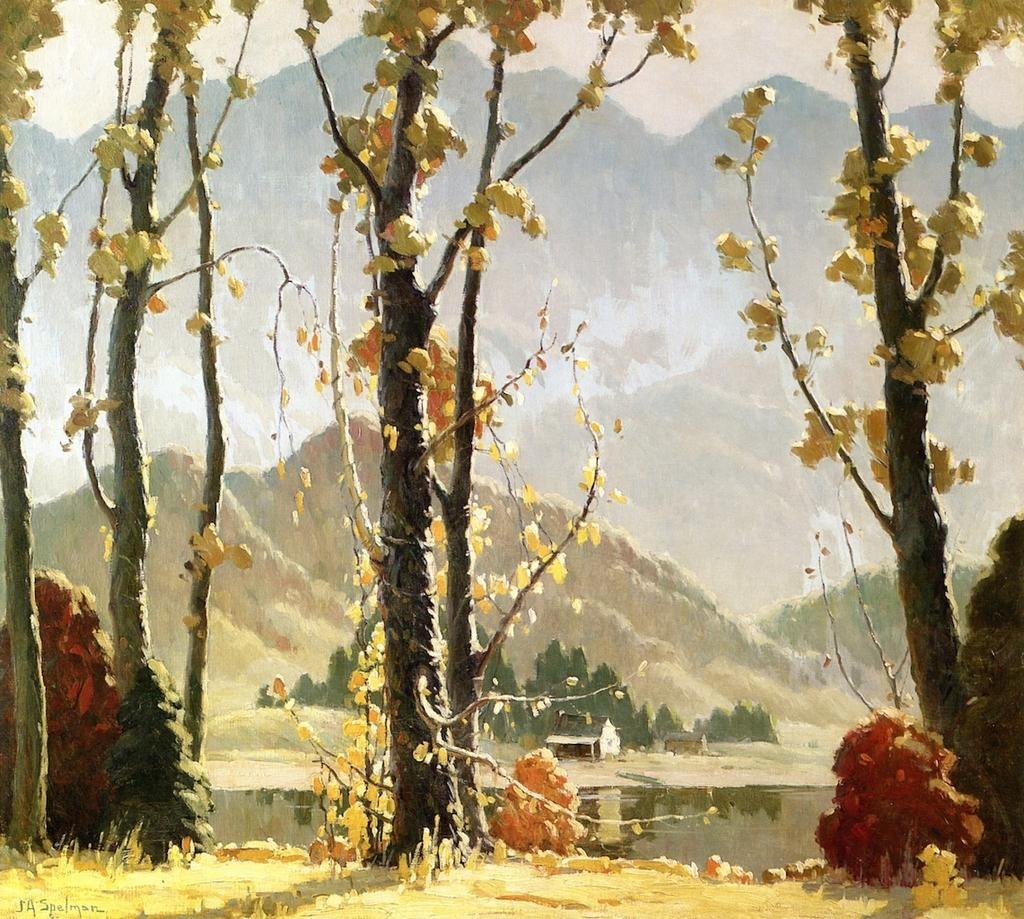What is the main subject of the painting? The painting depicts a scenery. What type of vegetation can be seen in the scenery? There are many trees in the scenery, and leaves are present as well. What natural feature is present in the scenery? There is a river in the scenery. What geographical feature can be seen in the background of the scenery? Mountains are visible in the scenery. Are there any man-made structures in the scenery? Yes, houses are present in the scenery. What type of pie is being served at the picnic in the painting? There is no picnic or pie present in the painting; it depicts a scenery with trees, a river, mountains, and houses. How many tickets are needed to enter the park in the painting? There is no park or tickets mentioned in the painting; it depicts a scenery with natural and man-made elements. 